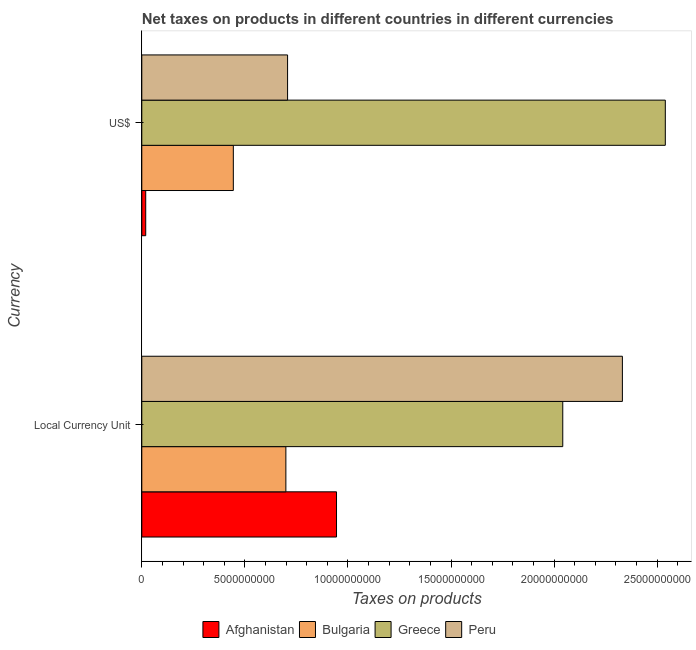How many groups of bars are there?
Your response must be concise. 2. Are the number of bars per tick equal to the number of legend labels?
Ensure brevity in your answer.  Yes. How many bars are there on the 1st tick from the bottom?
Offer a very short reply. 4. What is the label of the 1st group of bars from the top?
Provide a succinct answer. US$. What is the net taxes in constant 2005 us$ in Afghanistan?
Give a very brief answer. 9.45e+09. Across all countries, what is the maximum net taxes in constant 2005 us$?
Ensure brevity in your answer.  2.33e+1. Across all countries, what is the minimum net taxes in us$?
Provide a short and direct response. 1.90e+08. In which country was the net taxes in constant 2005 us$ minimum?
Ensure brevity in your answer.  Bulgaria. What is the total net taxes in us$ in the graph?
Your answer should be very brief. 3.71e+1. What is the difference between the net taxes in us$ in Greece and that in Bulgaria?
Your answer should be compact. 2.10e+1. What is the difference between the net taxes in constant 2005 us$ in Greece and the net taxes in us$ in Afghanistan?
Your response must be concise. 2.02e+1. What is the average net taxes in us$ per country?
Give a very brief answer. 9.27e+09. What is the difference between the net taxes in constant 2005 us$ and net taxes in us$ in Peru?
Make the answer very short. 1.62e+1. In how many countries, is the net taxes in constant 2005 us$ greater than 24000000000 units?
Keep it short and to the point. 0. What is the ratio of the net taxes in us$ in Afghanistan to that in Peru?
Make the answer very short. 0.03. In how many countries, is the net taxes in us$ greater than the average net taxes in us$ taken over all countries?
Your response must be concise. 1. What does the 3rd bar from the top in US$ represents?
Provide a short and direct response. Bulgaria. What does the 1st bar from the bottom in Local Currency Unit represents?
Your answer should be compact. Afghanistan. How many countries are there in the graph?
Keep it short and to the point. 4. Are the values on the major ticks of X-axis written in scientific E-notation?
Ensure brevity in your answer.  No. How many legend labels are there?
Offer a terse response. 4. How are the legend labels stacked?
Provide a short and direct response. Horizontal. What is the title of the graph?
Provide a short and direct response. Net taxes on products in different countries in different currencies. What is the label or title of the X-axis?
Offer a very short reply. Taxes on products. What is the label or title of the Y-axis?
Make the answer very short. Currency. What is the Taxes on products of Afghanistan in Local Currency Unit?
Make the answer very short. 9.45e+09. What is the Taxes on products of Bulgaria in Local Currency Unit?
Your answer should be compact. 6.99e+09. What is the Taxes on products in Greece in Local Currency Unit?
Give a very brief answer. 2.04e+1. What is the Taxes on products of Peru in Local Currency Unit?
Your answer should be very brief. 2.33e+1. What is the Taxes on products in Afghanistan in US$?
Offer a terse response. 1.90e+08. What is the Taxes on products of Bulgaria in US$?
Make the answer very short. 4.44e+09. What is the Taxes on products of Greece in US$?
Offer a terse response. 2.54e+1. What is the Taxes on products in Peru in US$?
Keep it short and to the point. 7.07e+09. Across all Currency, what is the maximum Taxes on products in Afghanistan?
Provide a short and direct response. 9.45e+09. Across all Currency, what is the maximum Taxes on products of Bulgaria?
Keep it short and to the point. 6.99e+09. Across all Currency, what is the maximum Taxes on products in Greece?
Give a very brief answer. 2.54e+1. Across all Currency, what is the maximum Taxes on products of Peru?
Offer a very short reply. 2.33e+1. Across all Currency, what is the minimum Taxes on products of Afghanistan?
Ensure brevity in your answer.  1.90e+08. Across all Currency, what is the minimum Taxes on products in Bulgaria?
Your answer should be compact. 4.44e+09. Across all Currency, what is the minimum Taxes on products of Greece?
Ensure brevity in your answer.  2.04e+1. Across all Currency, what is the minimum Taxes on products of Peru?
Your answer should be compact. 7.07e+09. What is the total Taxes on products in Afghanistan in the graph?
Provide a short and direct response. 9.64e+09. What is the total Taxes on products in Bulgaria in the graph?
Your answer should be compact. 1.14e+1. What is the total Taxes on products in Greece in the graph?
Make the answer very short. 4.58e+1. What is the total Taxes on products in Peru in the graph?
Provide a succinct answer. 3.04e+1. What is the difference between the Taxes on products in Afghanistan in Local Currency Unit and that in US$?
Give a very brief answer. 9.26e+09. What is the difference between the Taxes on products in Bulgaria in Local Currency Unit and that in US$?
Give a very brief answer. 2.55e+09. What is the difference between the Taxes on products in Greece in Local Currency Unit and that in US$?
Offer a very short reply. -4.98e+09. What is the difference between the Taxes on products in Peru in Local Currency Unit and that in US$?
Your response must be concise. 1.62e+1. What is the difference between the Taxes on products of Afghanistan in Local Currency Unit and the Taxes on products of Bulgaria in US$?
Offer a very short reply. 5.01e+09. What is the difference between the Taxes on products in Afghanistan in Local Currency Unit and the Taxes on products in Greece in US$?
Provide a succinct answer. -1.60e+1. What is the difference between the Taxes on products in Afghanistan in Local Currency Unit and the Taxes on products in Peru in US$?
Your answer should be compact. 2.37e+09. What is the difference between the Taxes on products in Bulgaria in Local Currency Unit and the Taxes on products in Greece in US$?
Provide a short and direct response. -1.84e+1. What is the difference between the Taxes on products in Bulgaria in Local Currency Unit and the Taxes on products in Peru in US$?
Provide a succinct answer. -8.28e+07. What is the difference between the Taxes on products of Greece in Local Currency Unit and the Taxes on products of Peru in US$?
Make the answer very short. 1.33e+1. What is the average Taxes on products in Afghanistan per Currency?
Give a very brief answer. 4.82e+09. What is the average Taxes on products of Bulgaria per Currency?
Your answer should be compact. 5.71e+09. What is the average Taxes on products of Greece per Currency?
Your answer should be very brief. 2.29e+1. What is the average Taxes on products in Peru per Currency?
Your response must be concise. 1.52e+1. What is the difference between the Taxes on products of Afghanistan and Taxes on products of Bulgaria in Local Currency Unit?
Ensure brevity in your answer.  2.46e+09. What is the difference between the Taxes on products of Afghanistan and Taxes on products of Greece in Local Currency Unit?
Offer a very short reply. -1.10e+1. What is the difference between the Taxes on products of Afghanistan and Taxes on products of Peru in Local Currency Unit?
Offer a terse response. -1.39e+1. What is the difference between the Taxes on products in Bulgaria and Taxes on products in Greece in Local Currency Unit?
Offer a terse response. -1.34e+1. What is the difference between the Taxes on products in Bulgaria and Taxes on products in Peru in Local Currency Unit?
Provide a short and direct response. -1.63e+1. What is the difference between the Taxes on products in Greece and Taxes on products in Peru in Local Currency Unit?
Make the answer very short. -2.89e+09. What is the difference between the Taxes on products in Afghanistan and Taxes on products in Bulgaria in US$?
Your answer should be very brief. -4.25e+09. What is the difference between the Taxes on products of Afghanistan and Taxes on products of Greece in US$?
Give a very brief answer. -2.52e+1. What is the difference between the Taxes on products of Afghanistan and Taxes on products of Peru in US$?
Offer a very short reply. -6.88e+09. What is the difference between the Taxes on products of Bulgaria and Taxes on products of Greece in US$?
Provide a succinct answer. -2.10e+1. What is the difference between the Taxes on products of Bulgaria and Taxes on products of Peru in US$?
Your answer should be compact. -2.63e+09. What is the difference between the Taxes on products in Greece and Taxes on products in Peru in US$?
Keep it short and to the point. 1.83e+1. What is the ratio of the Taxes on products in Afghanistan in Local Currency Unit to that in US$?
Your response must be concise. 49.63. What is the ratio of the Taxes on products of Bulgaria in Local Currency Unit to that in US$?
Make the answer very short. 1.57. What is the ratio of the Taxes on products in Greece in Local Currency Unit to that in US$?
Give a very brief answer. 0.8. What is the ratio of the Taxes on products of Peru in Local Currency Unit to that in US$?
Keep it short and to the point. 3.3. What is the difference between the highest and the second highest Taxes on products in Afghanistan?
Provide a succinct answer. 9.26e+09. What is the difference between the highest and the second highest Taxes on products of Bulgaria?
Offer a very short reply. 2.55e+09. What is the difference between the highest and the second highest Taxes on products in Greece?
Your answer should be very brief. 4.98e+09. What is the difference between the highest and the second highest Taxes on products of Peru?
Offer a terse response. 1.62e+1. What is the difference between the highest and the lowest Taxes on products in Afghanistan?
Your response must be concise. 9.26e+09. What is the difference between the highest and the lowest Taxes on products of Bulgaria?
Provide a short and direct response. 2.55e+09. What is the difference between the highest and the lowest Taxes on products of Greece?
Offer a very short reply. 4.98e+09. What is the difference between the highest and the lowest Taxes on products in Peru?
Offer a terse response. 1.62e+1. 